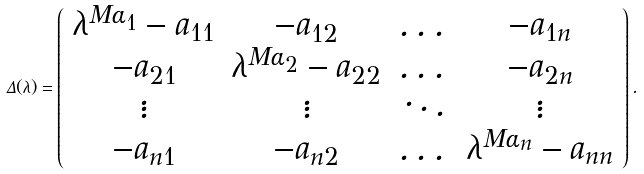<formula> <loc_0><loc_0><loc_500><loc_500>\Delta ( \lambda ) = \left ( \begin{array} { c c c c } \lambda ^ { M \alpha _ { 1 } } - a _ { 1 1 } & - a _ { 1 2 } & \dots & - a _ { 1 n } \\ - a _ { 2 1 } & \lambda ^ { M \alpha _ { 2 } } - a _ { 2 2 } & \dots & - a _ { 2 n } \\ \vdots & \vdots & \ddots & \vdots \\ - a _ { n 1 } & - a _ { n 2 } & \dots & \lambda ^ { M \alpha _ { n } } - a _ { n n } \\ \end{array} \right ) .</formula> 